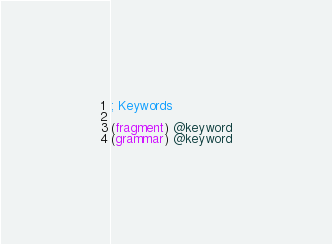Convert code to text. <code><loc_0><loc_0><loc_500><loc_500><_Scheme_>; Keywords

(fragment) @keyword
(grammar) @keyword
</code> 